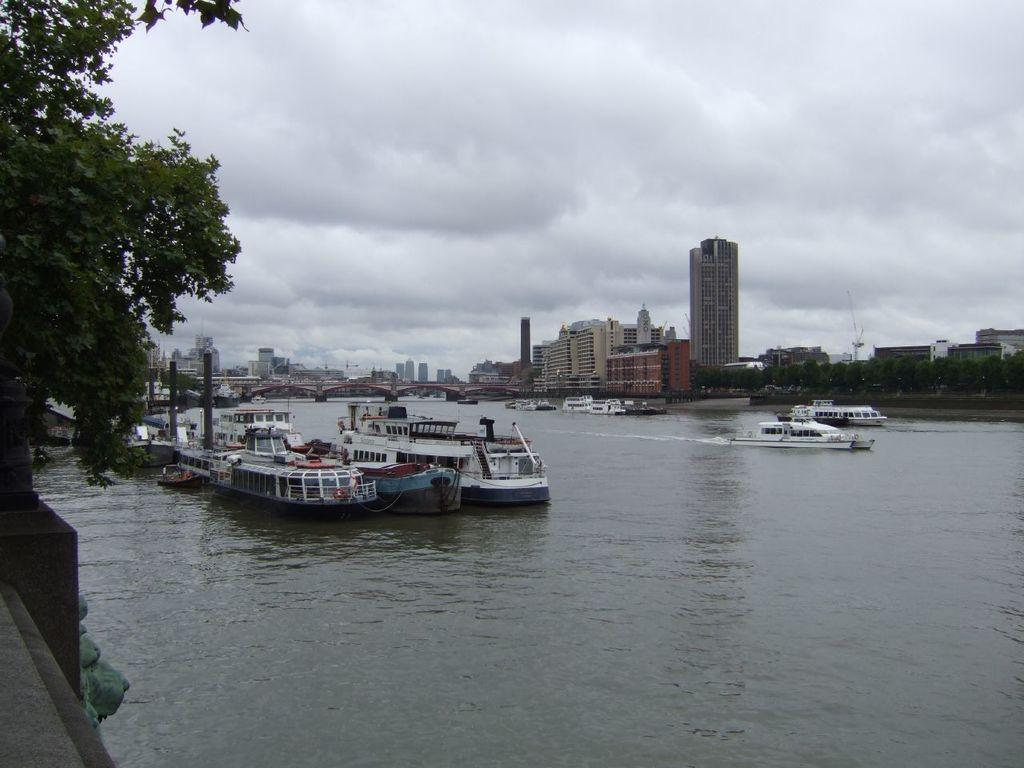What type of water body can be seen in the image? Ships are sailing on a lake in the image. What structure is present on the lake? There is a bridge on the lake. What can be seen in the background of the image? Buildings are visible in the background of the image. What type of vegetation is on the left side of the image? There is a tree on the left side of the image. How would you describe the weather in the image? The sky is cloudy in the top part of the image, suggesting overcast or cloudy weather. What type of food is being served on the bridge in the image? There is no food visible in the image, and the bridge is not serving any food. Can you see the sun in the image? The sky is cloudy in the top part of the image, so the sun is not visible. 